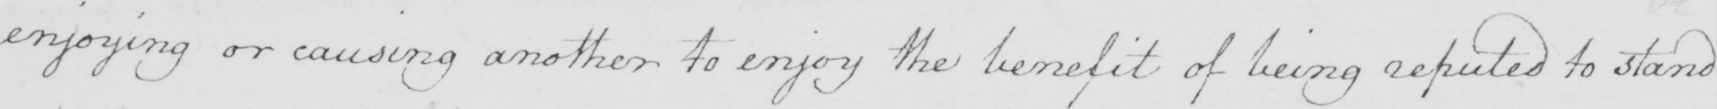Can you read and transcribe this handwriting? enjoying or causing another to enjoy the benefit of being reputed to stand 